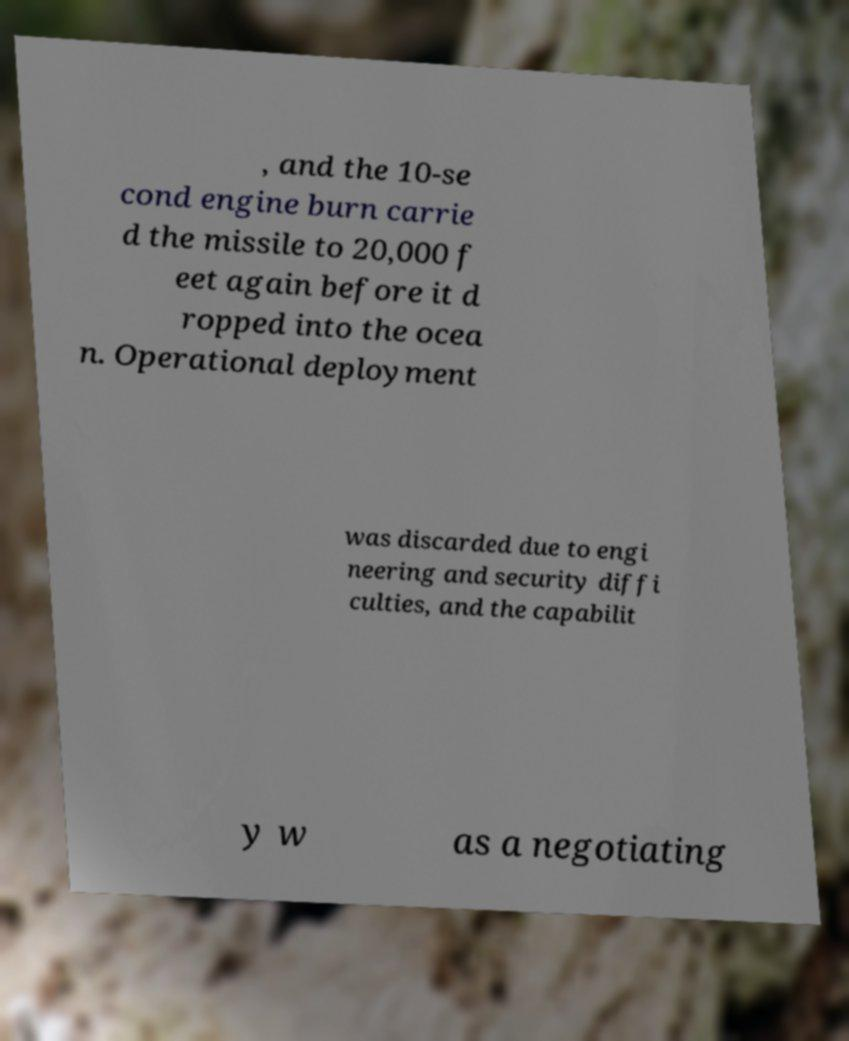Please identify and transcribe the text found in this image. , and the 10-se cond engine burn carrie d the missile to 20,000 f eet again before it d ropped into the ocea n. Operational deployment was discarded due to engi neering and security diffi culties, and the capabilit y w as a negotiating 